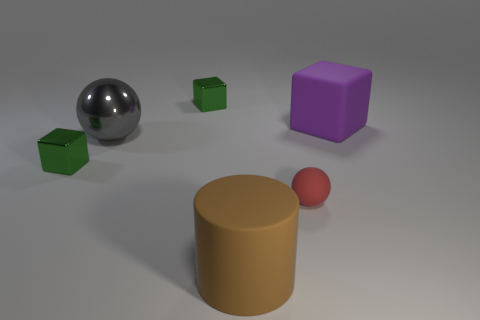What number of rubber cylinders are the same size as the brown matte thing?
Offer a terse response. 0. The small object that is the same material as the big brown thing is what shape?
Provide a succinct answer. Sphere. Are there any cylinders of the same color as the matte sphere?
Give a very brief answer. No. What material is the purple block?
Keep it short and to the point. Rubber. What number of objects are big brown metal cubes or large brown rubber objects?
Give a very brief answer. 1. How big is the block that is in front of the purple rubber cube?
Provide a short and direct response. Small. How many other things are there of the same material as the large ball?
Your answer should be compact. 2. There is a large object right of the tiny sphere; is there a brown object to the right of it?
Offer a very short reply. No. Is there any other thing that has the same shape as the gray shiny object?
Offer a very short reply. Yes. What color is the tiny rubber object that is the same shape as the large gray object?
Your answer should be compact. Red. 